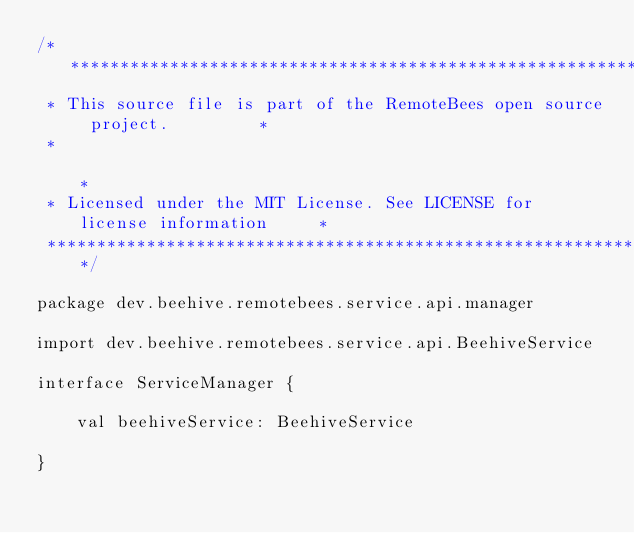Convert code to text. <code><loc_0><loc_0><loc_500><loc_500><_Kotlin_>/***************************************************************************
 * This source file is part of the RemoteBees open source project.         *
 *                                                                         *
 * Licensed under the MIT License. See LICENSE for license information     *
 ***************************************************************************/

package dev.beehive.remotebees.service.api.manager

import dev.beehive.remotebees.service.api.BeehiveService

interface ServiceManager {

    val beehiveService: BeehiveService

}
</code> 